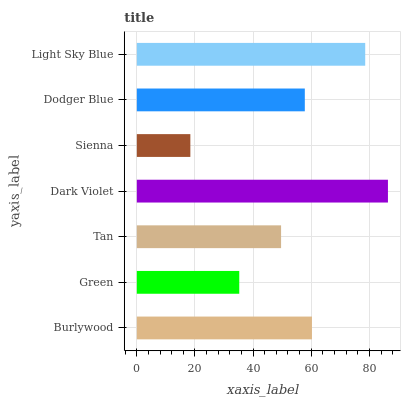Is Sienna the minimum?
Answer yes or no. Yes. Is Dark Violet the maximum?
Answer yes or no. Yes. Is Green the minimum?
Answer yes or no. No. Is Green the maximum?
Answer yes or no. No. Is Burlywood greater than Green?
Answer yes or no. Yes. Is Green less than Burlywood?
Answer yes or no. Yes. Is Green greater than Burlywood?
Answer yes or no. No. Is Burlywood less than Green?
Answer yes or no. No. Is Dodger Blue the high median?
Answer yes or no. Yes. Is Dodger Blue the low median?
Answer yes or no. Yes. Is Burlywood the high median?
Answer yes or no. No. Is Dark Violet the low median?
Answer yes or no. No. 